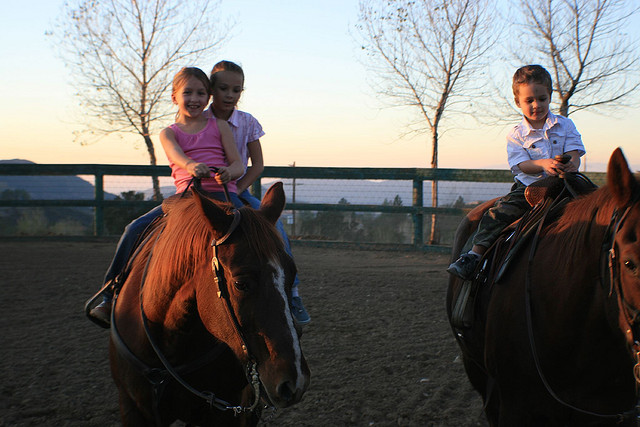<image>What are these men's jobs? It's unclear what these men's jobs are. They could be related to horse training or riding. What are these men's jobs? I don't know what these men's jobs are. It can be horse training, riding horses, giving horse rides, or something else. 